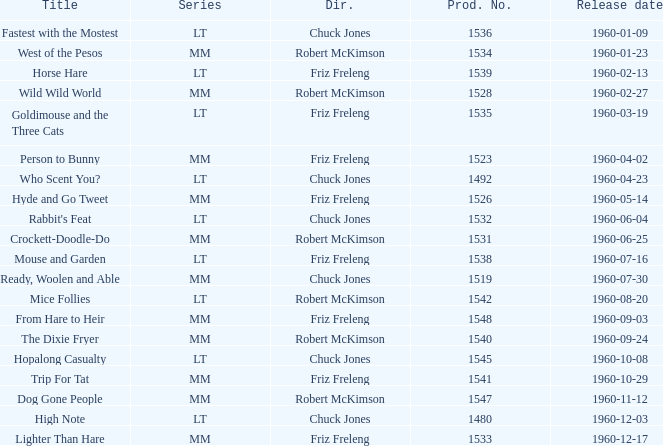What is the production number for the episode directed by Robert McKimson named Mice Follies? 1.0. 